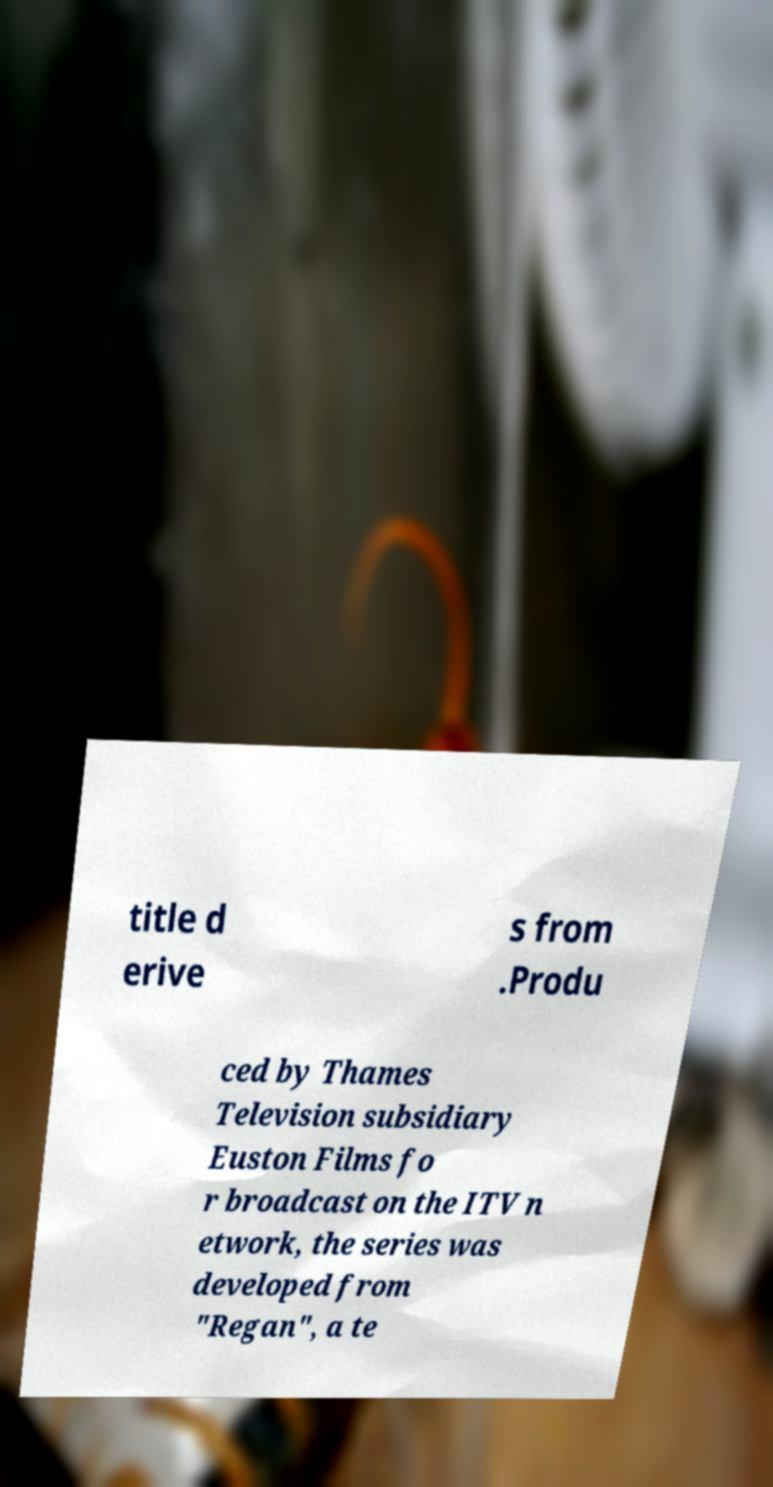I need the written content from this picture converted into text. Can you do that? title d erive s from .Produ ced by Thames Television subsidiary Euston Films fo r broadcast on the ITV n etwork, the series was developed from "Regan", a te 